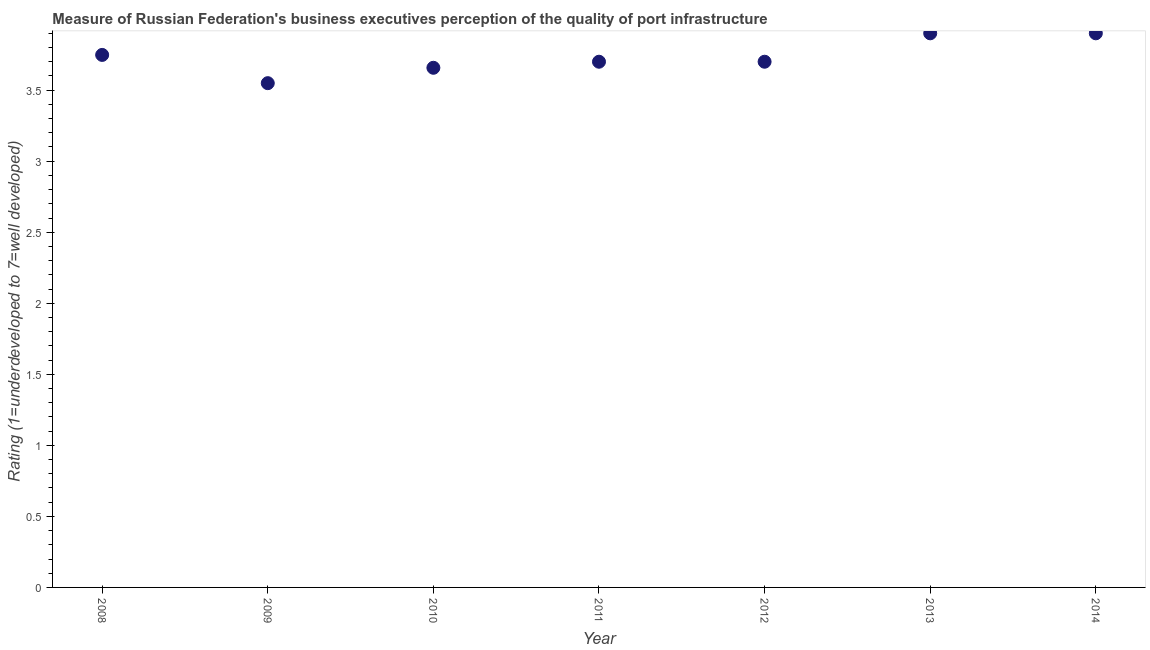What is the rating measuring quality of port infrastructure in 2010?
Your answer should be compact. 3.66. Across all years, what is the minimum rating measuring quality of port infrastructure?
Ensure brevity in your answer.  3.55. In which year was the rating measuring quality of port infrastructure maximum?
Provide a short and direct response. 2013. What is the sum of the rating measuring quality of port infrastructure?
Offer a very short reply. 26.15. What is the difference between the rating measuring quality of port infrastructure in 2009 and 2012?
Provide a short and direct response. -0.15. What is the average rating measuring quality of port infrastructure per year?
Ensure brevity in your answer.  3.74. What is the median rating measuring quality of port infrastructure?
Offer a terse response. 3.7. In how many years, is the rating measuring quality of port infrastructure greater than 2.9 ?
Keep it short and to the point. 7. What is the ratio of the rating measuring quality of port infrastructure in 2010 to that in 2012?
Keep it short and to the point. 0.99. What is the difference between the highest and the lowest rating measuring quality of port infrastructure?
Ensure brevity in your answer.  0.35. Does the rating measuring quality of port infrastructure monotonically increase over the years?
Your answer should be compact. No. How many dotlines are there?
Ensure brevity in your answer.  1. How many years are there in the graph?
Provide a succinct answer. 7. What is the difference between two consecutive major ticks on the Y-axis?
Make the answer very short. 0.5. Does the graph contain grids?
Make the answer very short. No. What is the title of the graph?
Make the answer very short. Measure of Russian Federation's business executives perception of the quality of port infrastructure. What is the label or title of the X-axis?
Make the answer very short. Year. What is the label or title of the Y-axis?
Offer a terse response. Rating (1=underdeveloped to 7=well developed) . What is the Rating (1=underdeveloped to 7=well developed)  in 2008?
Give a very brief answer. 3.75. What is the Rating (1=underdeveloped to 7=well developed)  in 2009?
Keep it short and to the point. 3.55. What is the Rating (1=underdeveloped to 7=well developed)  in 2010?
Provide a short and direct response. 3.66. What is the difference between the Rating (1=underdeveloped to 7=well developed)  in 2008 and 2009?
Offer a very short reply. 0.2. What is the difference between the Rating (1=underdeveloped to 7=well developed)  in 2008 and 2010?
Offer a very short reply. 0.09. What is the difference between the Rating (1=underdeveloped to 7=well developed)  in 2008 and 2011?
Give a very brief answer. 0.05. What is the difference between the Rating (1=underdeveloped to 7=well developed)  in 2008 and 2012?
Provide a succinct answer. 0.05. What is the difference between the Rating (1=underdeveloped to 7=well developed)  in 2008 and 2013?
Make the answer very short. -0.15. What is the difference between the Rating (1=underdeveloped to 7=well developed)  in 2008 and 2014?
Make the answer very short. -0.15. What is the difference between the Rating (1=underdeveloped to 7=well developed)  in 2009 and 2010?
Your response must be concise. -0.11. What is the difference between the Rating (1=underdeveloped to 7=well developed)  in 2009 and 2011?
Provide a short and direct response. -0.15. What is the difference between the Rating (1=underdeveloped to 7=well developed)  in 2009 and 2012?
Provide a short and direct response. -0.15. What is the difference between the Rating (1=underdeveloped to 7=well developed)  in 2009 and 2013?
Your response must be concise. -0.35. What is the difference between the Rating (1=underdeveloped to 7=well developed)  in 2009 and 2014?
Your answer should be compact. -0.35. What is the difference between the Rating (1=underdeveloped to 7=well developed)  in 2010 and 2011?
Provide a short and direct response. -0.04. What is the difference between the Rating (1=underdeveloped to 7=well developed)  in 2010 and 2012?
Your answer should be compact. -0.04. What is the difference between the Rating (1=underdeveloped to 7=well developed)  in 2010 and 2013?
Your response must be concise. -0.24. What is the difference between the Rating (1=underdeveloped to 7=well developed)  in 2010 and 2014?
Provide a short and direct response. -0.24. What is the difference between the Rating (1=underdeveloped to 7=well developed)  in 2011 and 2013?
Make the answer very short. -0.2. What is the difference between the Rating (1=underdeveloped to 7=well developed)  in 2011 and 2014?
Provide a short and direct response. -0.2. What is the ratio of the Rating (1=underdeveloped to 7=well developed)  in 2008 to that in 2009?
Keep it short and to the point. 1.06. What is the ratio of the Rating (1=underdeveloped to 7=well developed)  in 2008 to that in 2010?
Your answer should be compact. 1.02. What is the ratio of the Rating (1=underdeveloped to 7=well developed)  in 2008 to that in 2011?
Ensure brevity in your answer.  1.01. What is the ratio of the Rating (1=underdeveloped to 7=well developed)  in 2008 to that in 2012?
Give a very brief answer. 1.01. What is the ratio of the Rating (1=underdeveloped to 7=well developed)  in 2008 to that in 2013?
Offer a terse response. 0.96. What is the ratio of the Rating (1=underdeveloped to 7=well developed)  in 2008 to that in 2014?
Provide a succinct answer. 0.96. What is the ratio of the Rating (1=underdeveloped to 7=well developed)  in 2009 to that in 2011?
Your answer should be compact. 0.96. What is the ratio of the Rating (1=underdeveloped to 7=well developed)  in 2009 to that in 2013?
Offer a terse response. 0.91. What is the ratio of the Rating (1=underdeveloped to 7=well developed)  in 2009 to that in 2014?
Ensure brevity in your answer.  0.91. What is the ratio of the Rating (1=underdeveloped to 7=well developed)  in 2010 to that in 2012?
Keep it short and to the point. 0.99. What is the ratio of the Rating (1=underdeveloped to 7=well developed)  in 2010 to that in 2013?
Give a very brief answer. 0.94. What is the ratio of the Rating (1=underdeveloped to 7=well developed)  in 2010 to that in 2014?
Give a very brief answer. 0.94. What is the ratio of the Rating (1=underdeveloped to 7=well developed)  in 2011 to that in 2012?
Your answer should be compact. 1. What is the ratio of the Rating (1=underdeveloped to 7=well developed)  in 2011 to that in 2013?
Provide a succinct answer. 0.95. What is the ratio of the Rating (1=underdeveloped to 7=well developed)  in 2011 to that in 2014?
Ensure brevity in your answer.  0.95. What is the ratio of the Rating (1=underdeveloped to 7=well developed)  in 2012 to that in 2013?
Offer a very short reply. 0.95. What is the ratio of the Rating (1=underdeveloped to 7=well developed)  in 2012 to that in 2014?
Your answer should be very brief. 0.95. 